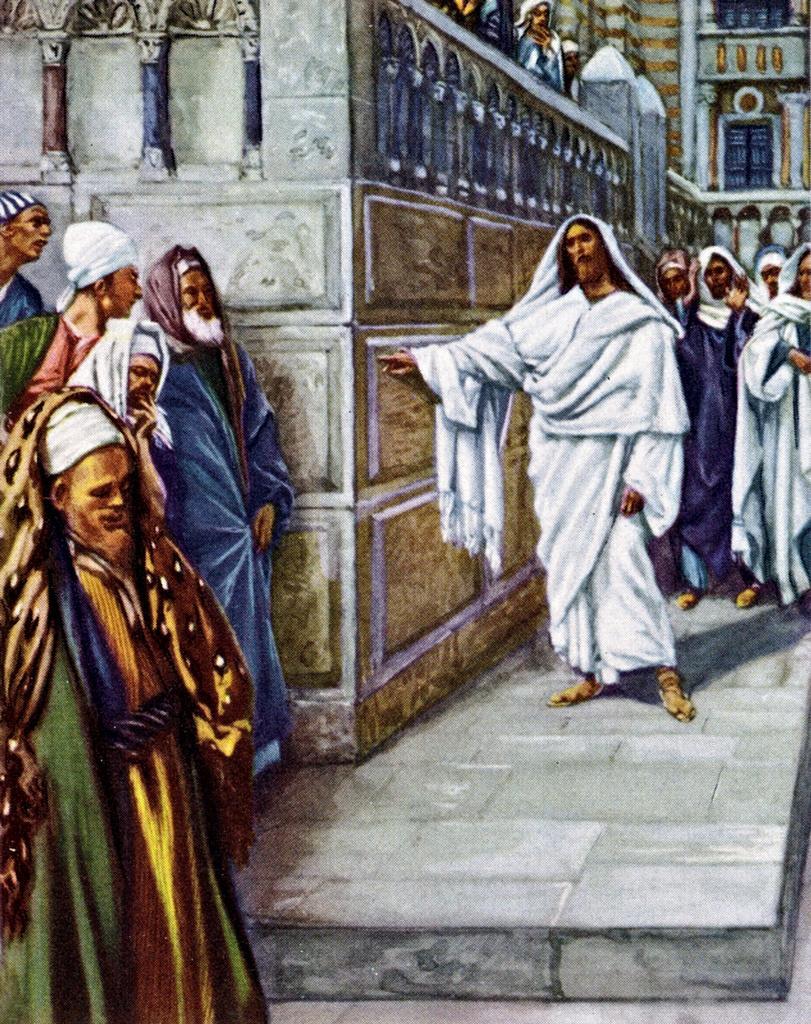Describe this image in one or two sentences. In this picture we can see a group of people standing on the floor and in the background we can see a building with windows and some people. 